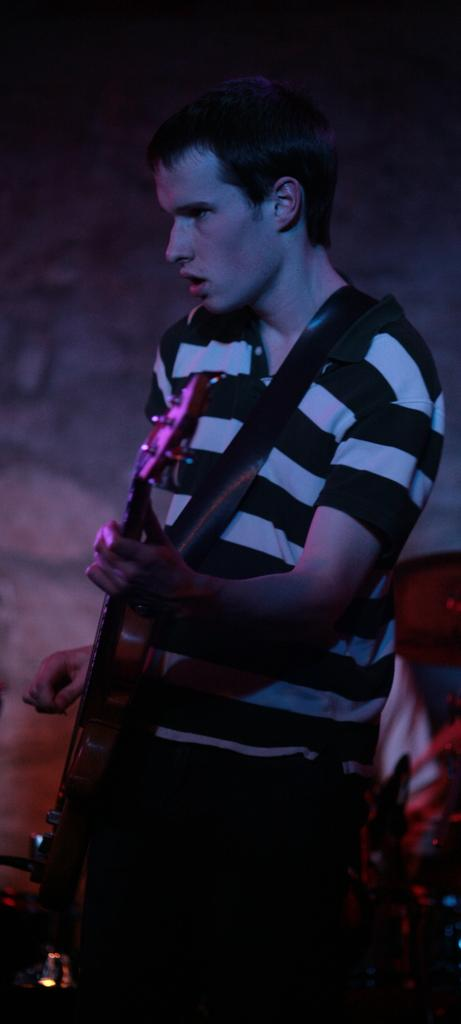What is the main subject of the image? There is a man in the image. Where is the man positioned in the image? The man is standing in the center. What is the man holding in his hand? The man is holding a guitar in his hand. What is the man doing in the image? The man is singing a song. What type of creature can be seen playing in the sand in the image? There is no creature or sand present in the image; it features a man holding a guitar and singing a song. 